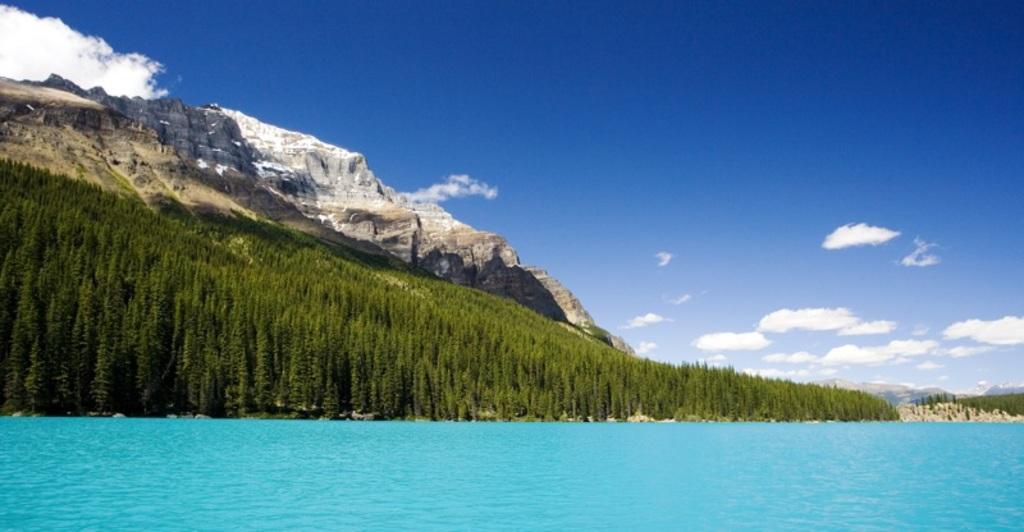In one or two sentences, can you explain what this image depicts? In front of the image there is a sea, behind the sea, there are trees and mountains, at the top of the image there are clouds in the sky. 